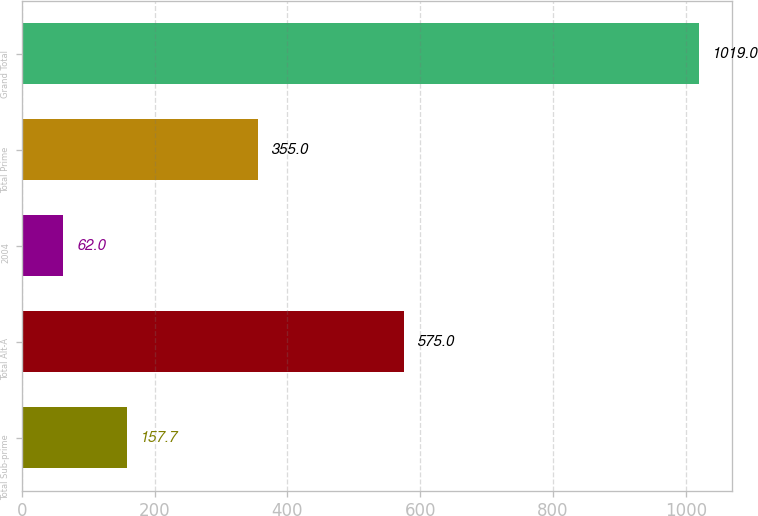<chart> <loc_0><loc_0><loc_500><loc_500><bar_chart><fcel>Total Sub-prime<fcel>Total Alt-A<fcel>2004<fcel>Total Prime<fcel>Grand Total<nl><fcel>157.7<fcel>575<fcel>62<fcel>355<fcel>1019<nl></chart> 